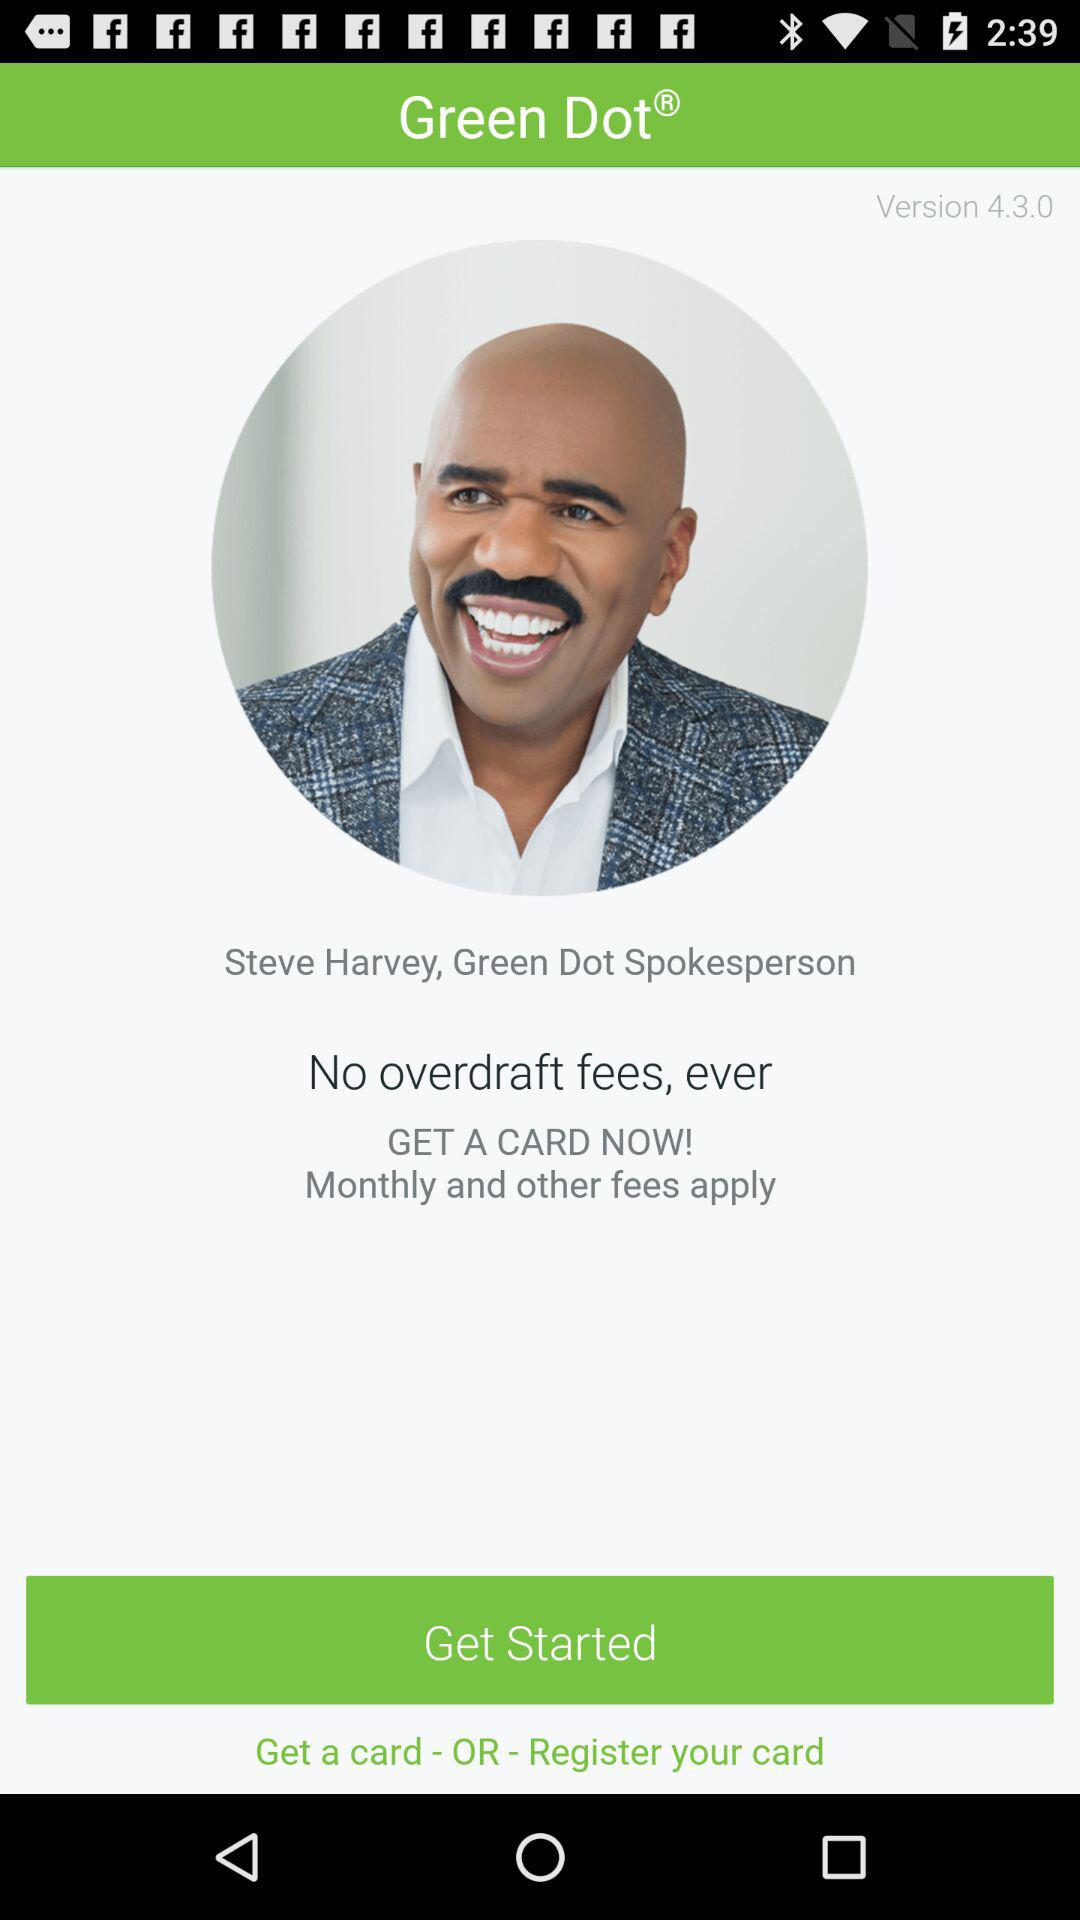What is the version? The version is 4.3.0. 